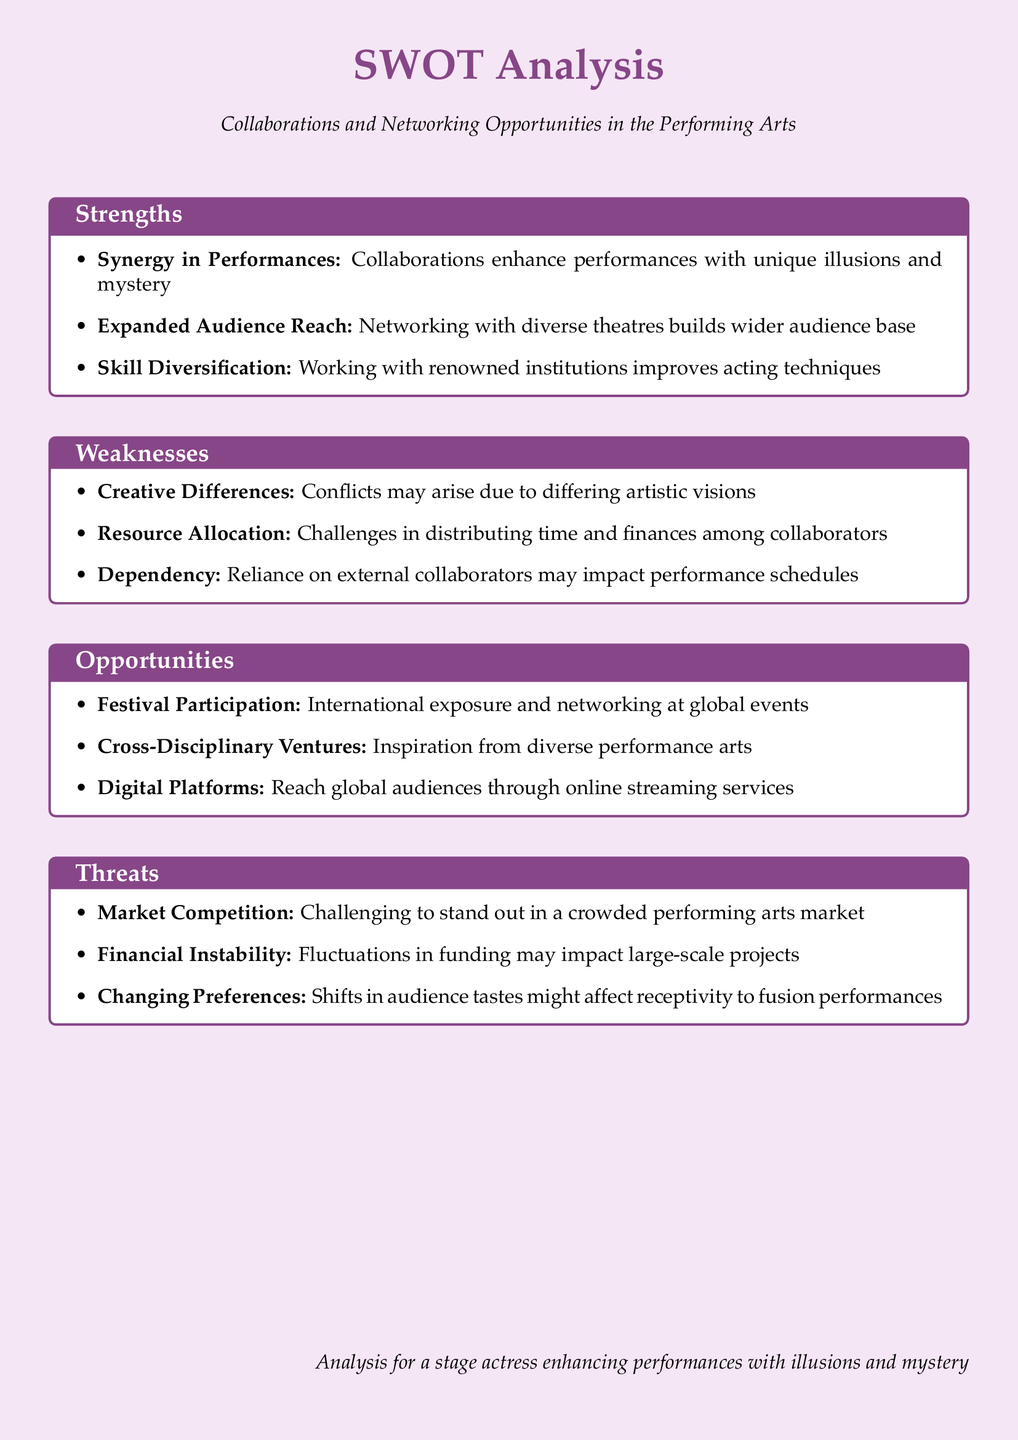what are three strengths of collaborations? The document lists strengths, including synergy in performances, expanded audience reach, and skill diversification.
Answer: synergy in performances, expanded audience reach, skill diversification what is a weakness related to creative processes? The document states that creative differences can lead to conflicts due to differing artistic visions.
Answer: creative differences how many opportunities are listed in the document? There are three opportunities mentioned in the document: festival participation, cross-disciplinary ventures, and digital platforms.
Answer: three what threat involves financial challenges? The document identifies financial instability as a threat that affects large-scale projects due to fluctuations in funding.
Answer: financial instability which strength enhances performances with unique aspects? The document highlights that synergy in performances is a strength that enhances performances with unique illusions and mystery.
Answer: synergy in performances what is one opportunity for reaching global audiences? The document mentions that digital platforms provide the opportunity to reach global audiences through online streaming services.
Answer: digital platforms 